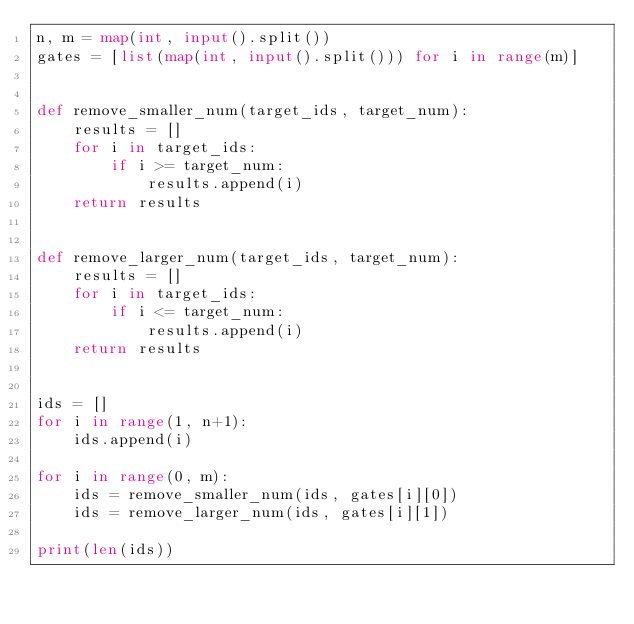<code> <loc_0><loc_0><loc_500><loc_500><_Python_>n, m = map(int, input().split())
gates = [list(map(int, input().split())) for i in range(m)]


def remove_smaller_num(target_ids, target_num):
    results = []
    for i in target_ids:
        if i >= target_num:
            results.append(i)
    return results


def remove_larger_num(target_ids, target_num):
    results = []
    for i in target_ids:
        if i <= target_num:
            results.append(i)
    return results


ids = []
for i in range(1, n+1):
    ids.append(i)

for i in range(0, m):
    ids = remove_smaller_num(ids, gates[i][0])
    ids = remove_larger_num(ids, gates[i][1])

print(len(ids))
</code> 